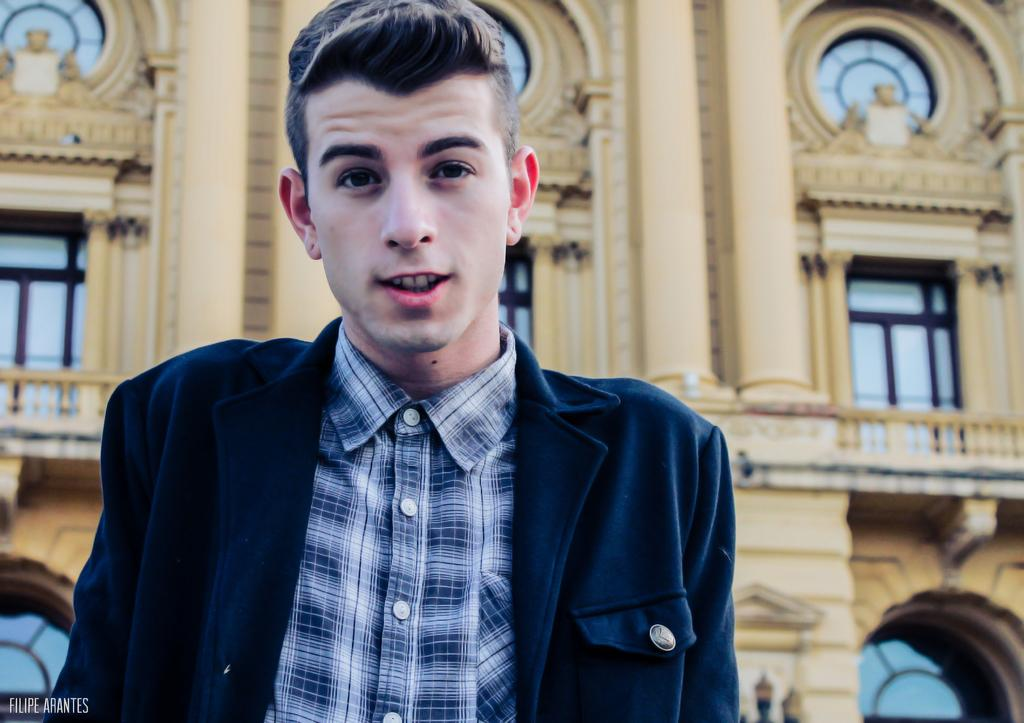Who is present in the image? There is a man in the image. What is the man wearing? The man is wearing a shirt and a coat. What can be seen in the background of the image? There is a building in the background of the image. Where is the text located in the image? The text is in the bottom left corner of the image. Reasoning: Let' Let's think step by step in order to produce the conversation. We start by identifying the main subject in the image, which is the man. Then, we describe his clothing, including the shirt and coat. Next, we mention the background of the image, which features a building. Finally, we point out the presence of text in the image and its location. Absurd Question/Answer: How many mice can be seen running through the hole in the image? There are no mice or holes present in the image. 